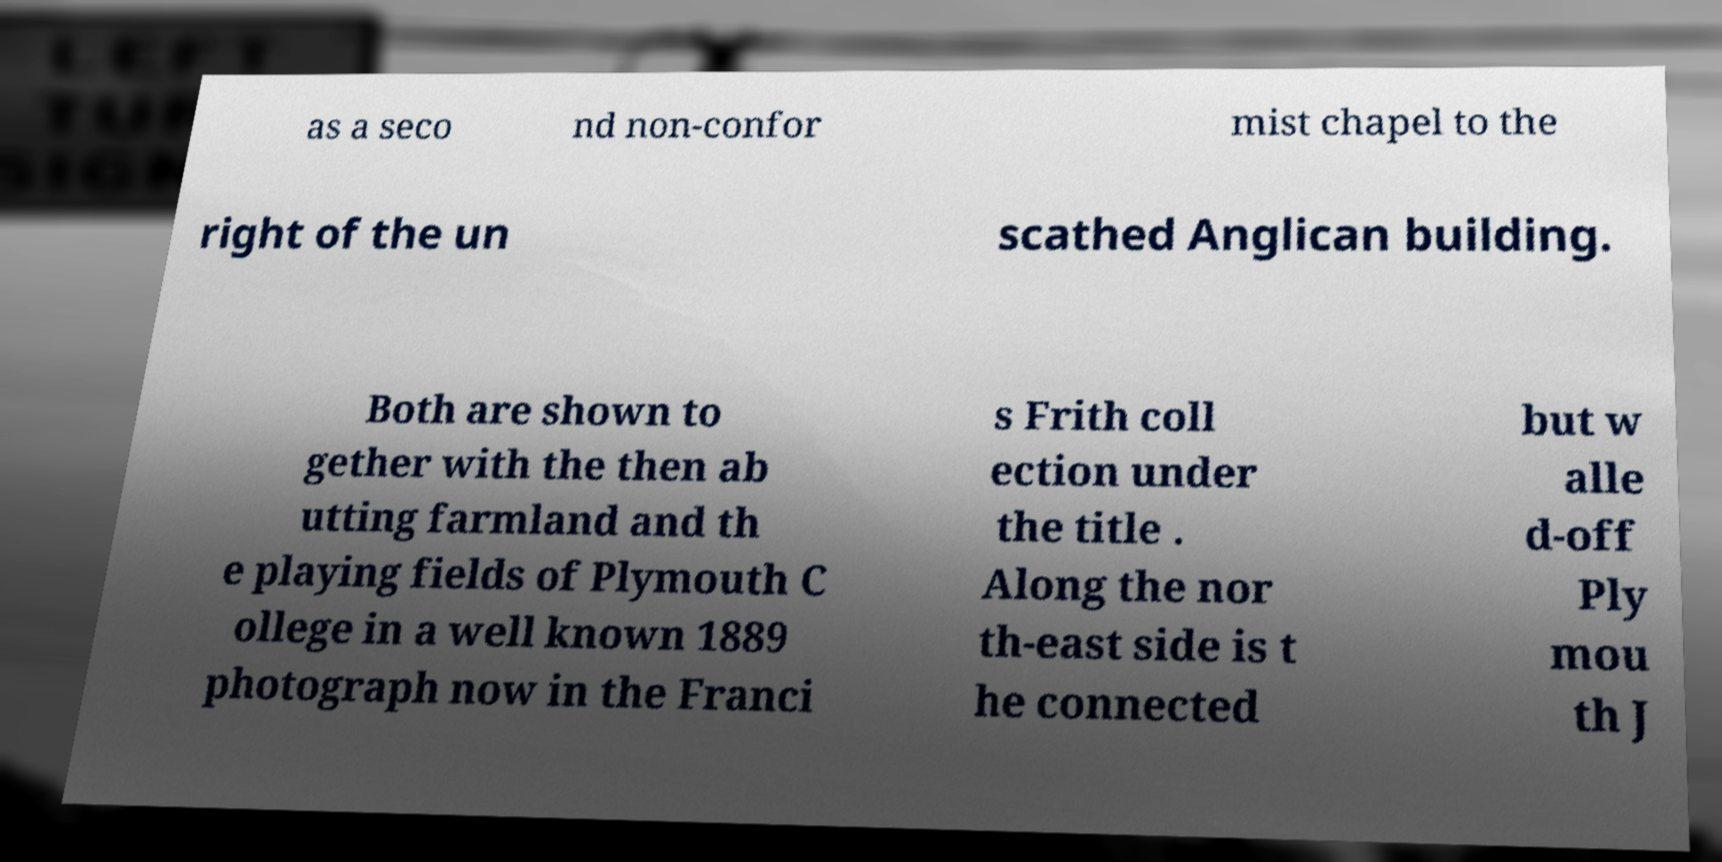Could you assist in decoding the text presented in this image and type it out clearly? as a seco nd non-confor mist chapel to the right of the un scathed Anglican building. Both are shown to gether with the then ab utting farmland and th e playing fields of Plymouth C ollege in a well known 1889 photograph now in the Franci s Frith coll ection under the title . Along the nor th-east side is t he connected but w alle d-off Ply mou th J 